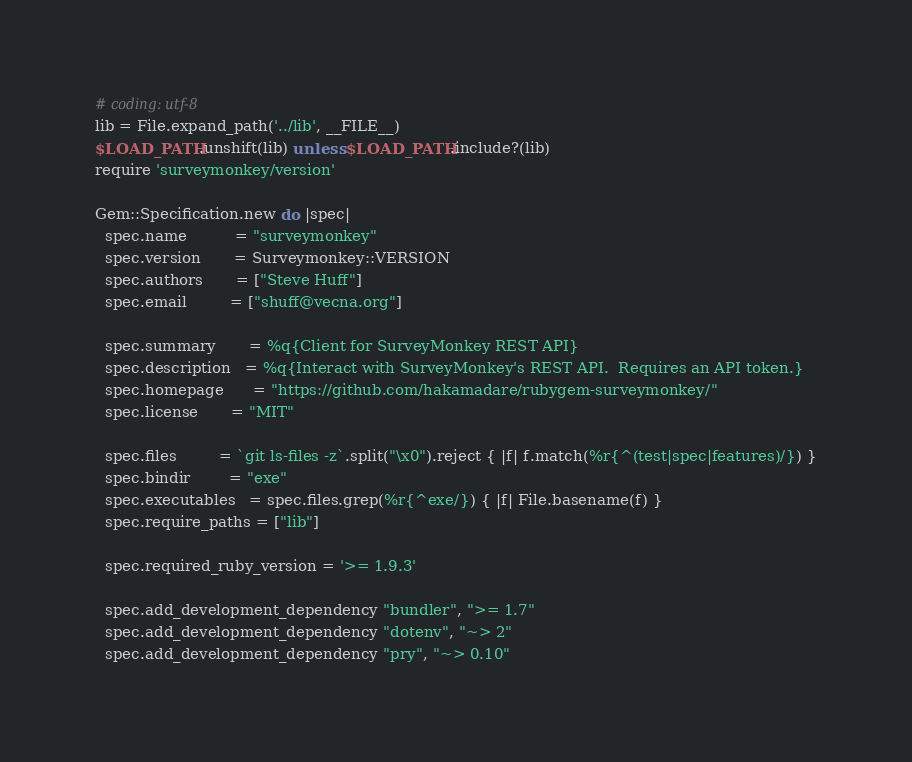Convert code to text. <code><loc_0><loc_0><loc_500><loc_500><_Ruby_># coding: utf-8
lib = File.expand_path('../lib', __FILE__)
$LOAD_PATH.unshift(lib) unless $LOAD_PATH.include?(lib)
require 'surveymonkey/version'

Gem::Specification.new do |spec|
  spec.name          = "surveymonkey"
  spec.version       = Surveymonkey::VERSION
  spec.authors       = ["Steve Huff"]
  spec.email         = ["shuff@vecna.org"]

  spec.summary       = %q{Client for SurveyMonkey REST API}
  spec.description   = %q{Interact with SurveyMonkey's REST API.  Requires an API token.}
  spec.homepage      = "https://github.com/hakamadare/rubygem-surveymonkey/"
  spec.license       = "MIT"

  spec.files         = `git ls-files -z`.split("\x0").reject { |f| f.match(%r{^(test|spec|features)/}) }
  spec.bindir        = "exe"
  spec.executables   = spec.files.grep(%r{^exe/}) { |f| File.basename(f) }
  spec.require_paths = ["lib"]

  spec.required_ruby_version = '>= 1.9.3'

  spec.add_development_dependency "bundler", ">= 1.7"
  spec.add_development_dependency "dotenv", "~> 2"
  spec.add_development_dependency "pry", "~> 0.10"</code> 